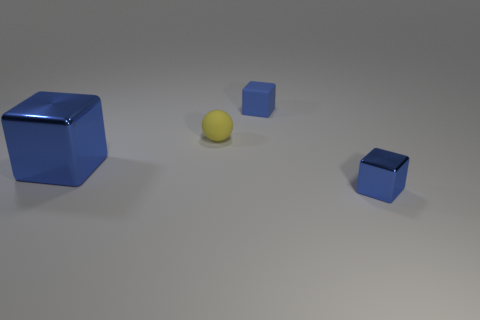What number of cubes are blue metallic things or small yellow objects?
Provide a succinct answer. 2. Do the cube right of the blue matte thing and the big blue thing have the same material?
Provide a succinct answer. Yes. How many large objects are either metal objects or red shiny spheres?
Give a very brief answer. 1. Do the rubber cube and the big metal block have the same color?
Your answer should be compact. Yes. Are there more small cubes that are in front of the tiny shiny thing than rubber blocks that are in front of the yellow thing?
Keep it short and to the point. No. There is a metallic object that is right of the large blue object; is its color the same as the tiny rubber block?
Make the answer very short. Yes. Is there any other thing that has the same color as the tiny rubber block?
Ensure brevity in your answer.  Yes. Are there more large blue cubes behind the small blue matte cube than tiny objects?
Provide a short and direct response. No. Do the blue matte object and the rubber sphere have the same size?
Your answer should be compact. Yes. There is a large blue thing that is the same shape as the tiny metallic thing; what material is it?
Ensure brevity in your answer.  Metal. 